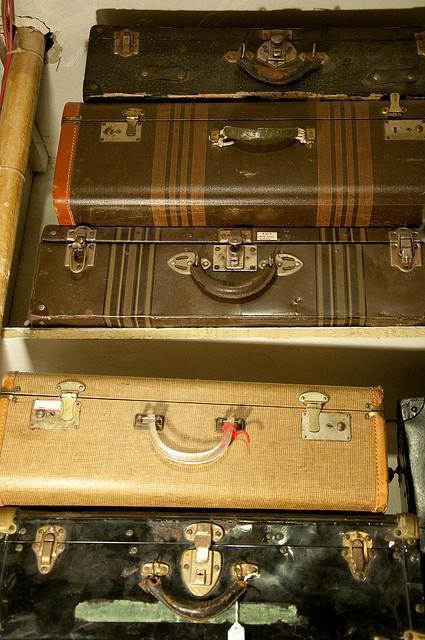How many suitcases have vertical stripes running down them?
Give a very brief answer. 2. How many suitcases can be seen?
Give a very brief answer. 2. How many yellow buses are in the picture?
Give a very brief answer. 0. 